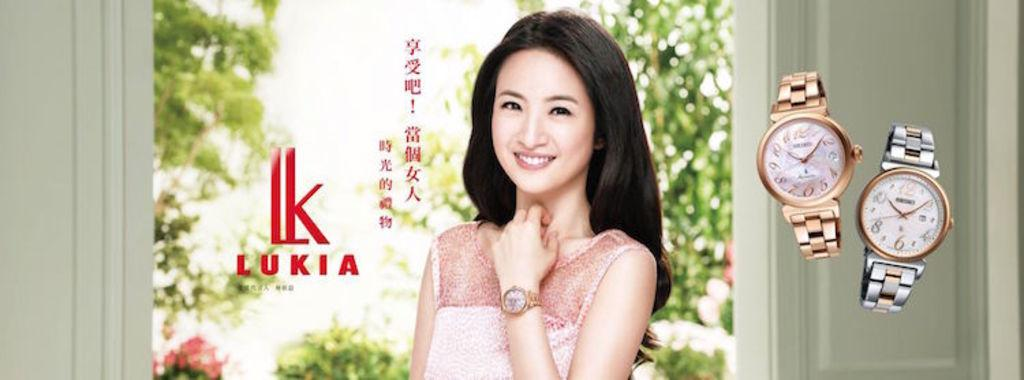<image>
Summarize the visual content of the image. A pretty model wearing a watch with 2 other watches by Lukia 